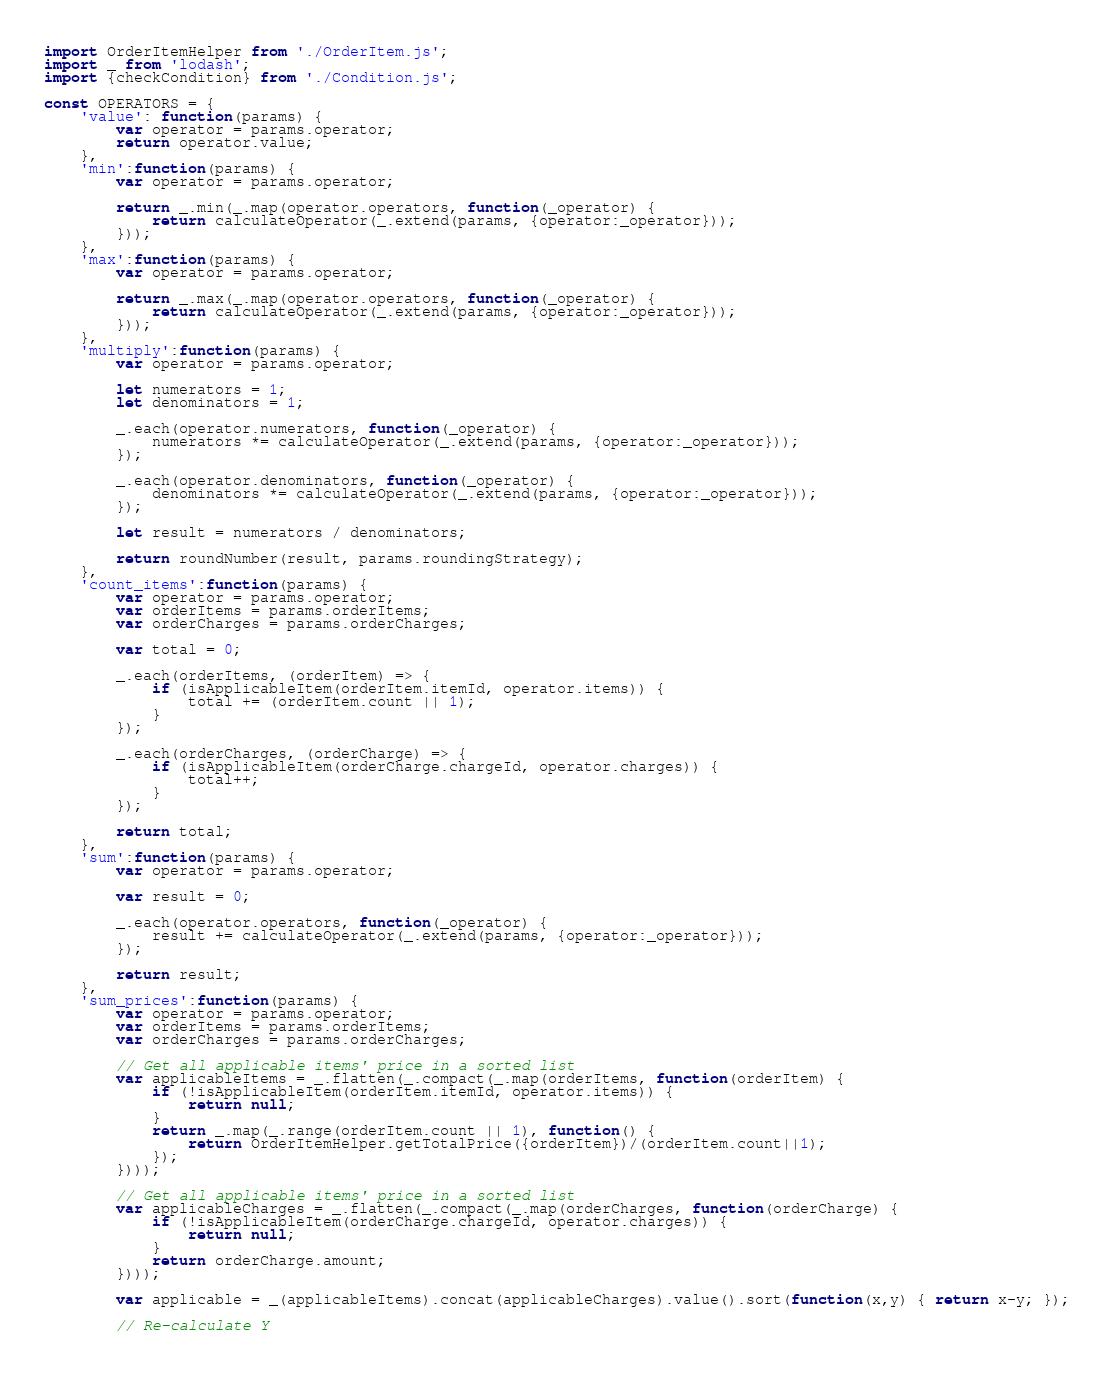Convert code to text. <code><loc_0><loc_0><loc_500><loc_500><_JavaScript_>import OrderItemHelper from './OrderItem.js';
import _ from 'lodash';
import {checkCondition} from './Condition.js';

const OPERATORS = {
    'value': function(params) {
        var operator = params.operator;
        return operator.value;
    },
    'min':function(params) {
        var operator = params.operator;

        return _.min(_.map(operator.operators, function(_operator) {
            return calculateOperator(_.extend(params, {operator:_operator}));
        }));
    },
    'max':function(params) {
        var operator = params.operator;

        return _.max(_.map(operator.operators, function(_operator) {
            return calculateOperator(_.extend(params, {operator:_operator}));
        }));
    },
    'multiply':function(params) {
        var operator = params.operator;

        let numerators = 1;
        let denominators = 1;

        _.each(operator.numerators, function(_operator) {
            numerators *= calculateOperator(_.extend(params, {operator:_operator}));
        });

        _.each(operator.denominators, function(_operator) {
            denominators *= calculateOperator(_.extend(params, {operator:_operator}));
        });

        let result = numerators / denominators;

        return roundNumber(result, params.roundingStrategy);
    },
    'count_items':function(params) {
        var operator = params.operator;
        var orderItems = params.orderItems;
        var orderCharges = params.orderCharges;

        var total = 0;

        _.each(orderItems, (orderItem) => {
            if (isApplicableItem(orderItem.itemId, operator.items)) {
                total += (orderItem.count || 1);
            }
        });

        _.each(orderCharges, (orderCharge) => {
            if (isApplicableItem(orderCharge.chargeId, operator.charges)) {
                total++;
            }
        });

        return total;
    },
    'sum':function(params) {
        var operator = params.operator;

        var result = 0;

        _.each(operator.operators, function(_operator) {
            result += calculateOperator(_.extend(params, {operator:_operator}));
        });

        return result;
    },
    'sum_prices':function(params) {
        var operator = params.operator;
        var orderItems = params.orderItems;
        var orderCharges = params.orderCharges;

        // Get all applicable items' price in a sorted list
        var applicableItems = _.flatten(_.compact(_.map(orderItems, function(orderItem) {
            if (!isApplicableItem(orderItem.itemId, operator.items)) {
                return null;
            }
            return _.map(_.range(orderItem.count || 1), function() {
                return OrderItemHelper.getTotalPrice({orderItem})/(orderItem.count||1);
            });
        })));

        // Get all applicable items' price in a sorted list
        var applicableCharges = _.flatten(_.compact(_.map(orderCharges, function(orderCharge) {
            if (!isApplicableItem(orderCharge.chargeId, operator.charges)) {
                return null;
            }
            return orderCharge.amount;
        })));

        var applicable = _(applicableItems).concat(applicableCharges).value().sort(function(x,y) { return x-y; });

        // Re-calculate Y</code> 